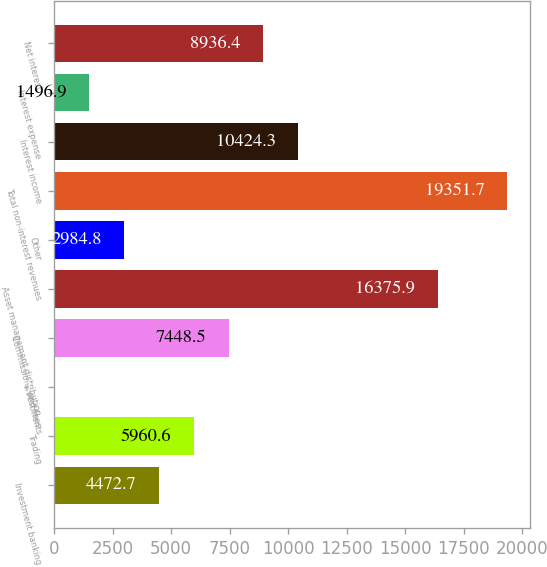Convert chart to OTSL. <chart><loc_0><loc_0><loc_500><loc_500><bar_chart><fcel>Investment banking<fcel>Trading<fcel>Investments<fcel>Commissions and fees<fcel>Asset management distribution<fcel>Other<fcel>Total non-interest revenues<fcel>Interest income<fcel>Interest expense<fcel>Net interest<nl><fcel>4472.7<fcel>5960.6<fcel>9<fcel>7448.5<fcel>16375.9<fcel>2984.8<fcel>19351.7<fcel>10424.3<fcel>1496.9<fcel>8936.4<nl></chart> 